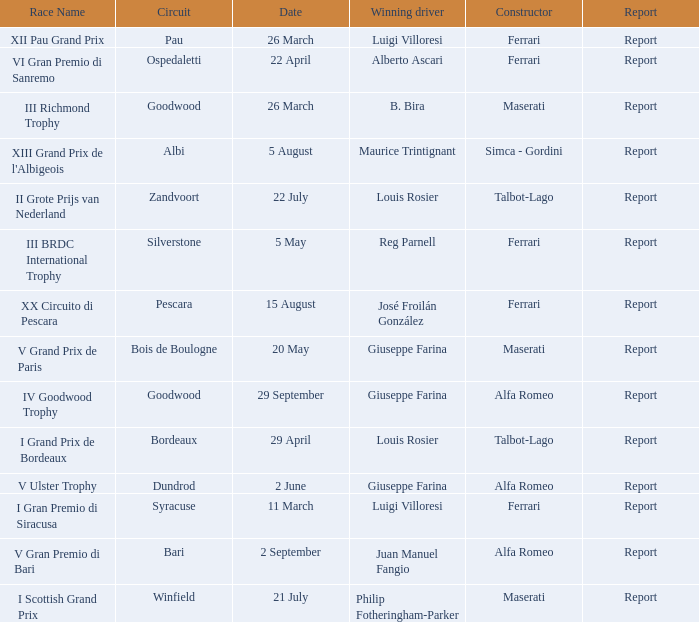Name the report for v grand prix de paris Report. 